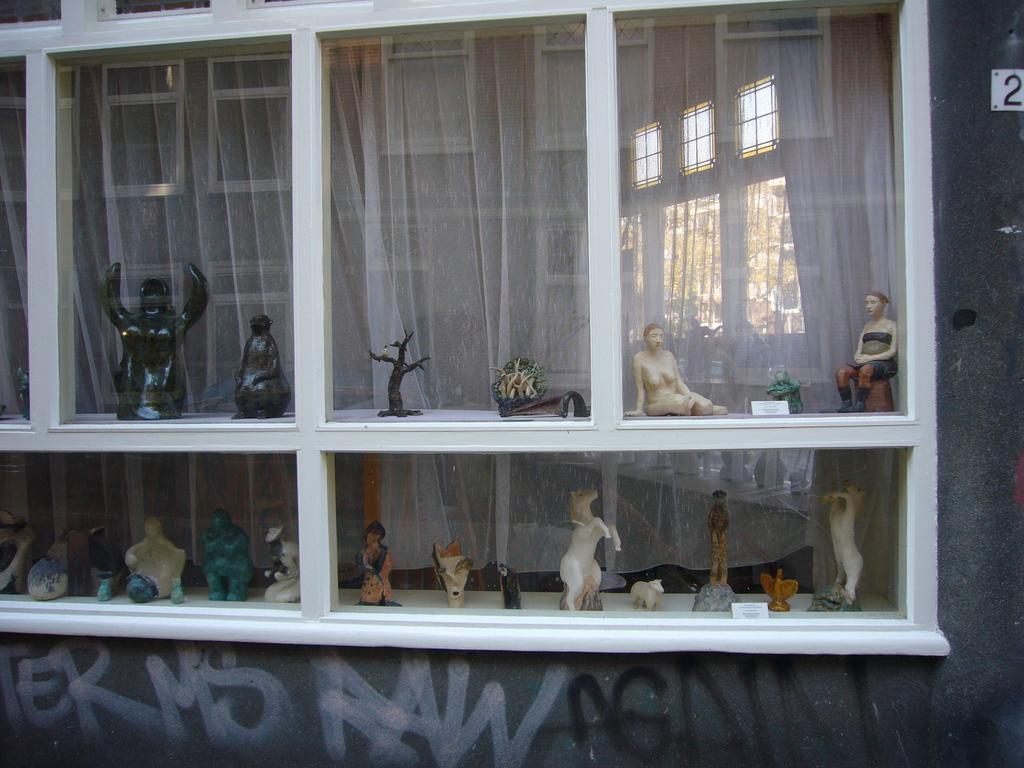Describe this image in one or two sentences. In this picture we can see statues in glass cupboard, behind this glass cupboard we can see curtain. We can see some text on the wall. 